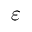Convert formula to latex. <formula><loc_0><loc_0><loc_500><loc_500>\varepsilon</formula> 